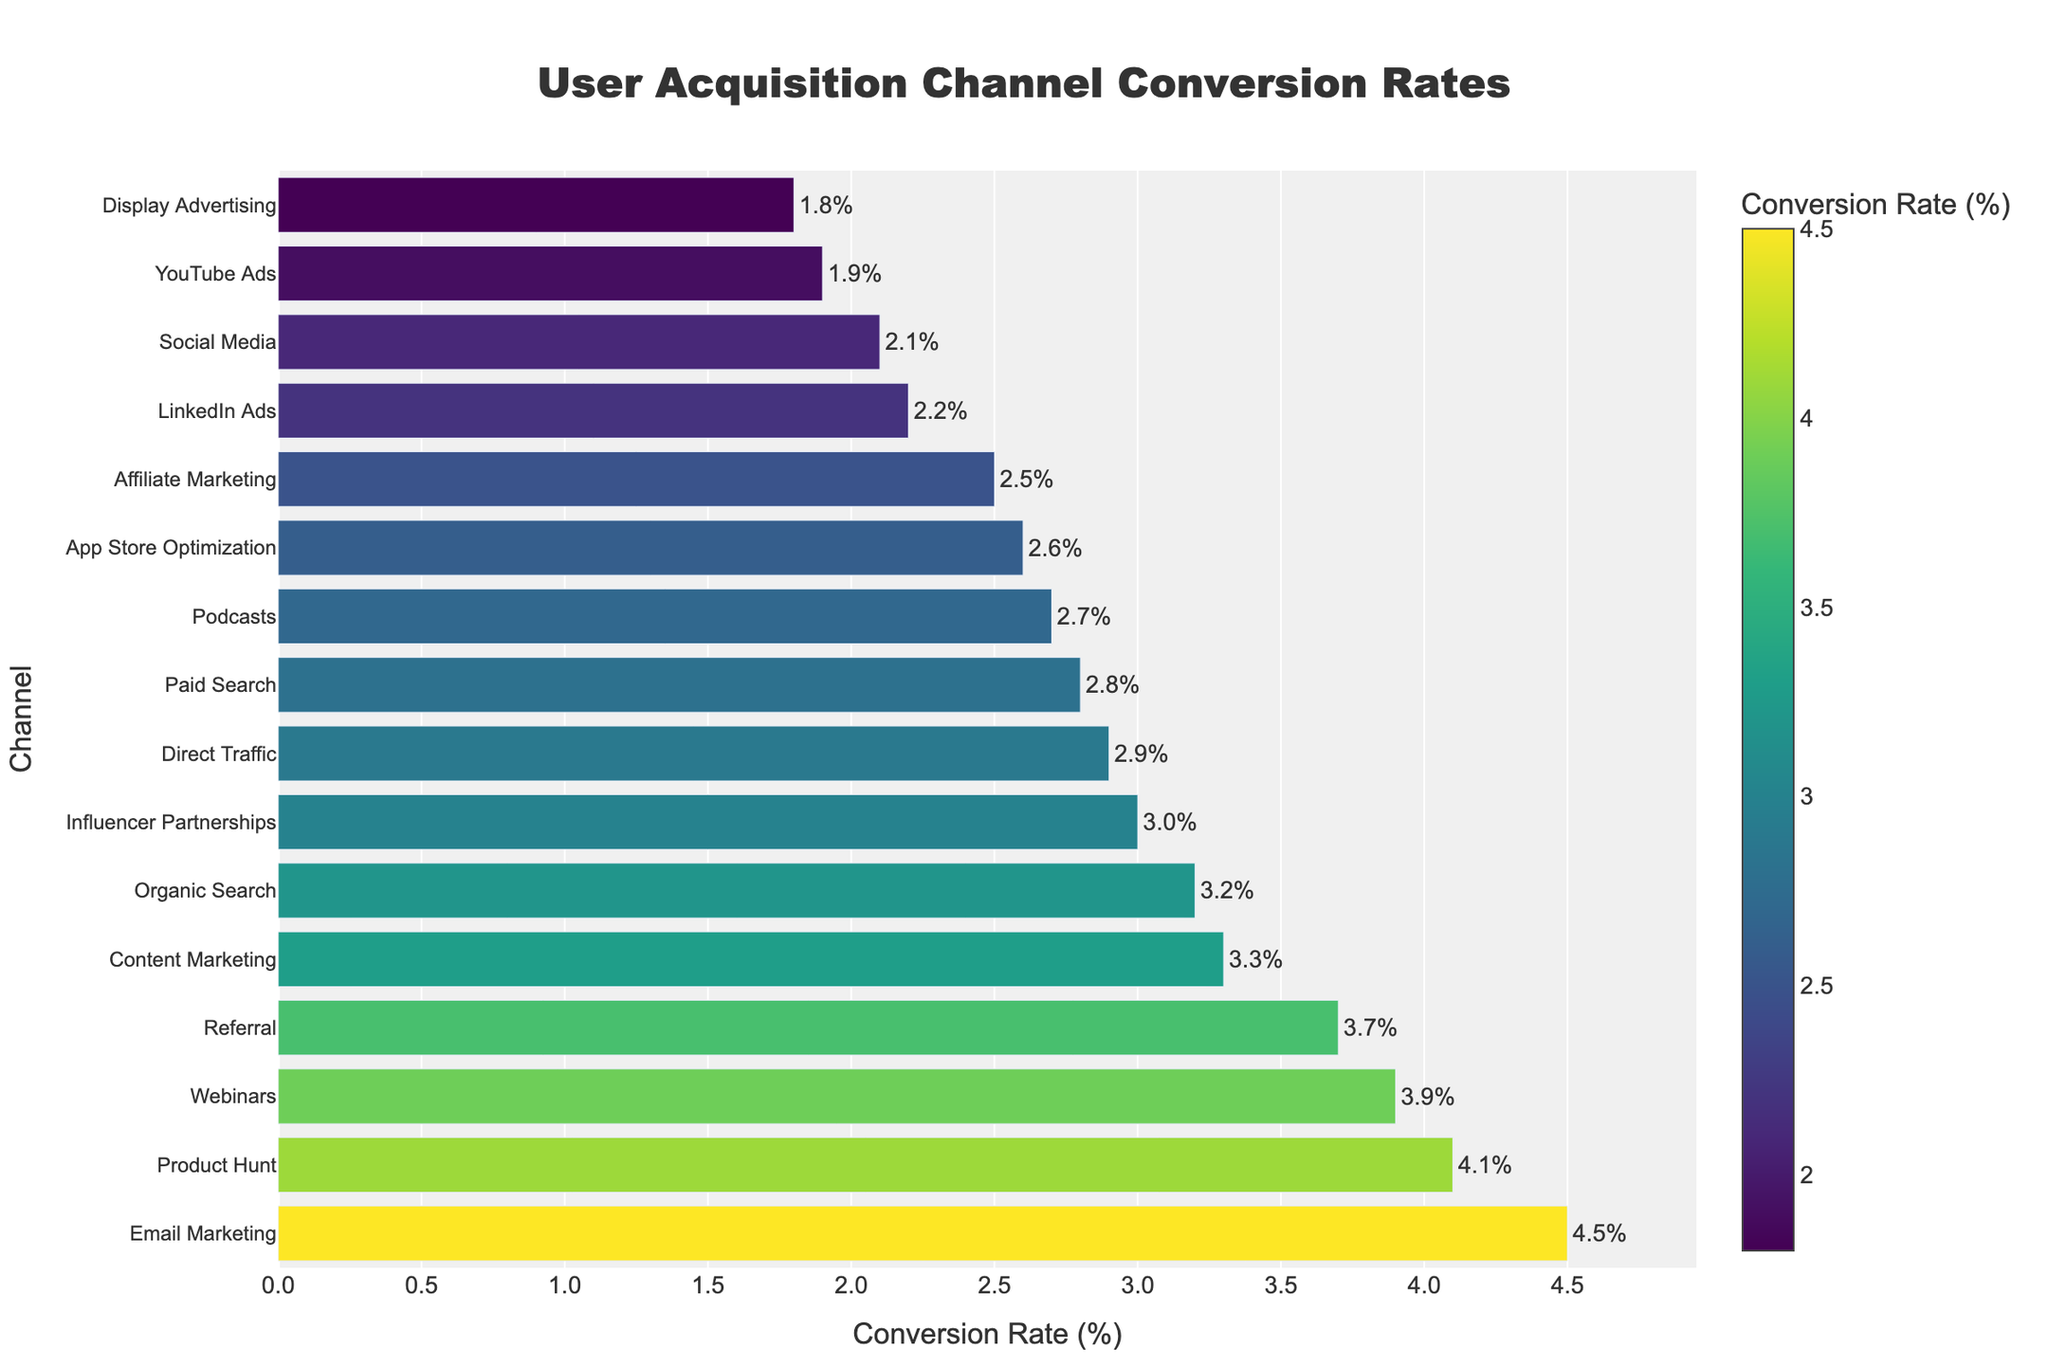What is the conversion rate of "Email Marketing"? Find "Email Marketing" on the y-axis and follow the bar's length to the x-axis value to find the conversion rate.
Answer: 4.5% Which acquisition channel has the highest conversion rate? Identify the bar that is the longest, and read its corresponding channel on the y-axis.
Answer: Email Marketing Which two channels have the lowest conversion rates? Locate the two shortest bars, then check their corresponding channels on the y-axis.
Answer: Display Advertising and YouTube Ads What is the difference in conversion rate between "Referral" and "Social Media"? Find the conversion rates for both "Referral" (3.7) and "Social Media" (2.1), then subtract the smaller value from the larger one. 3.7 - 2.1 = 1.6
Answer: 1.6 What is the average conversion rate of "Influencer Partnerships," "Podcasts," and "LinkedIn Ads"? Find the conversion rates for "Influencer Partnerships" (3.0), "Podcasts" (2.7), and "LinkedIn Ads" (2.2); sum them up, and divide by 3. (3.0 + 2.7 + 2.2) / 3 = 2.633
Answer: 2.633 Which acquisition channel has a higher conversion rate: "Webinars" or "Product Hunt"? Compare the lengths of the bars for "Webinars" (3.9) and "Product Hunt" (4.1)
Answer: Product Hunt How does the conversion rate of "Organic Search" compare to the average conversion rate of all channels? Calculate the average conversion rate by summing all conversion rates and dividing by the number of channels. Compare "Organic Search" (3.2) to this average.
Answer: Less than average Which channel has a conversion rate closest to 3%. Identify the bar closest to the 3% mark on the x-axis and check its corresponding channel on the y-axis.
Answer: Influencer Partnerships 